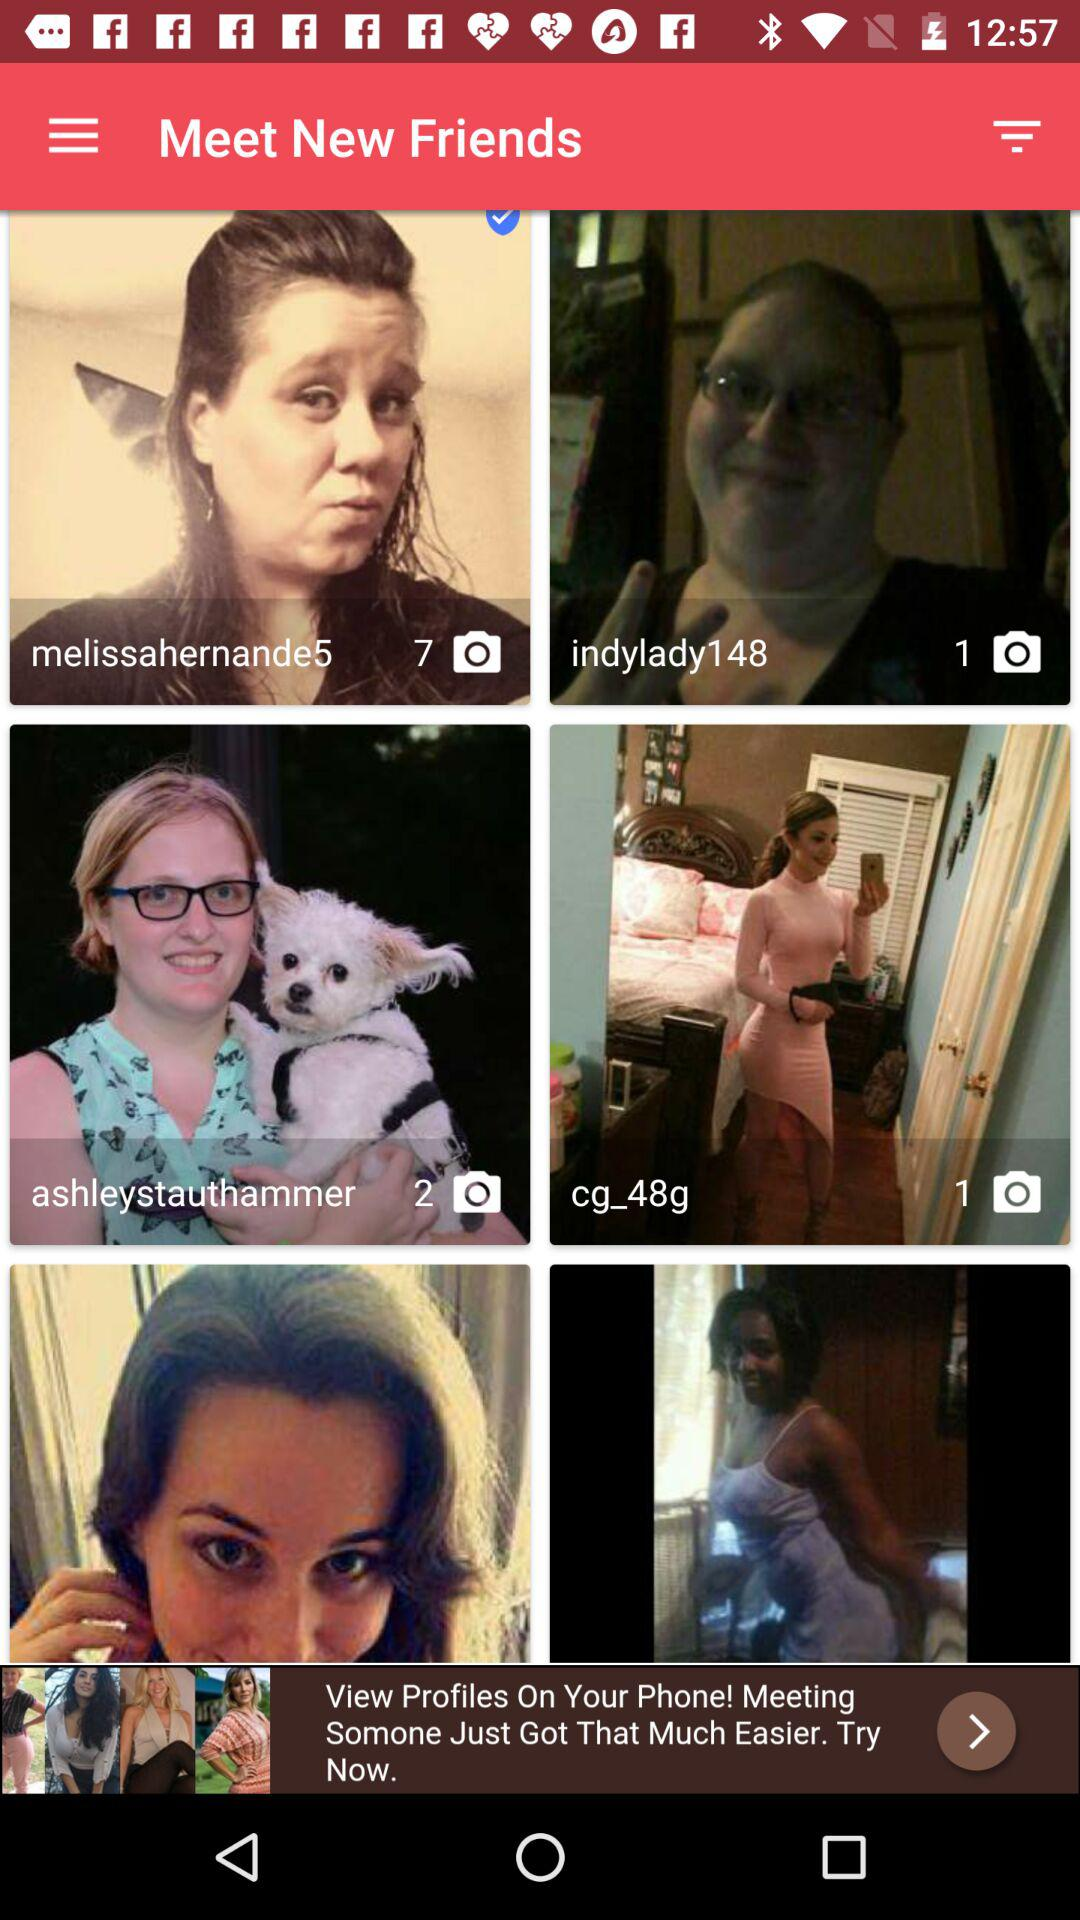How many images are there in the "melissahernande5" folder? There are 7 images in the "melissahernande5" folder. 